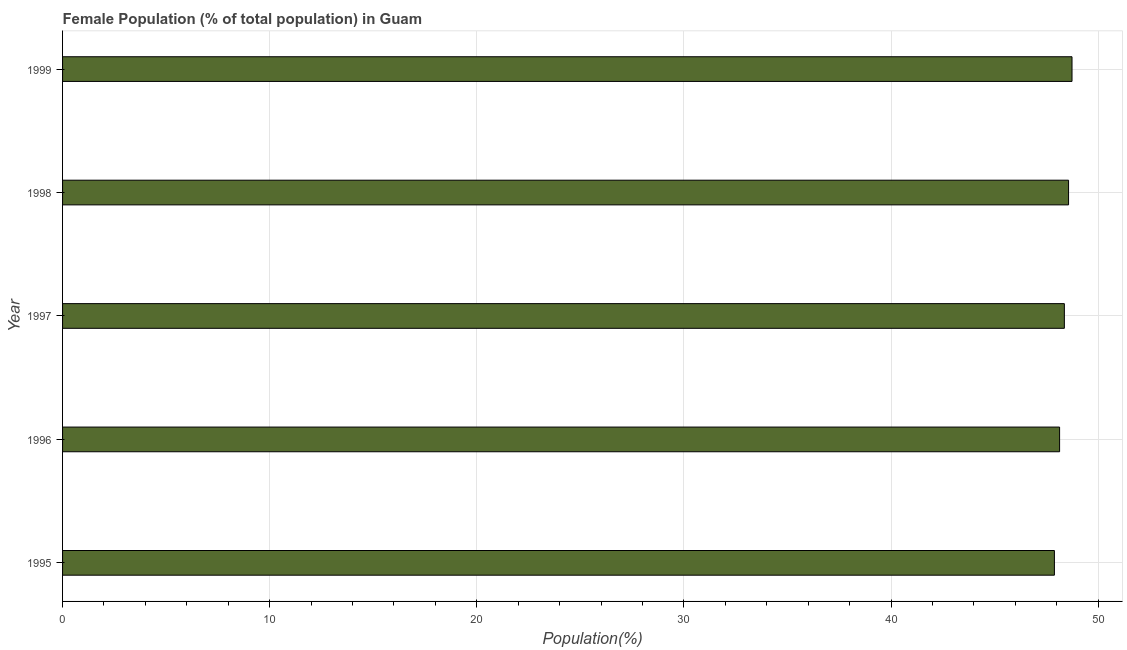What is the title of the graph?
Your answer should be compact. Female Population (% of total population) in Guam. What is the label or title of the X-axis?
Keep it short and to the point. Population(%). What is the female population in 1998?
Provide a succinct answer. 48.57. Across all years, what is the maximum female population?
Provide a succinct answer. 48.74. Across all years, what is the minimum female population?
Ensure brevity in your answer.  47.89. In which year was the female population minimum?
Make the answer very short. 1995. What is the sum of the female population?
Give a very brief answer. 241.7. What is the difference between the female population in 1995 and 1998?
Offer a terse response. -0.68. What is the average female population per year?
Make the answer very short. 48.34. What is the median female population?
Provide a succinct answer. 48.37. In how many years, is the female population greater than 22 %?
Provide a short and direct response. 5. Do a majority of the years between 1999 and 1996 (inclusive) have female population greater than 20 %?
Your response must be concise. Yes. What is the ratio of the female population in 1996 to that in 1998?
Your answer should be very brief. 0.99. Is the female population in 1997 less than that in 1999?
Your answer should be very brief. Yes. What is the difference between the highest and the second highest female population?
Make the answer very short. 0.17. What is the difference between the highest and the lowest female population?
Offer a terse response. 0.85. How many bars are there?
Offer a very short reply. 5. Are all the bars in the graph horizontal?
Your answer should be compact. Yes. How many years are there in the graph?
Your answer should be compact. 5. Are the values on the major ticks of X-axis written in scientific E-notation?
Your answer should be very brief. No. What is the Population(%) of 1995?
Ensure brevity in your answer.  47.89. What is the Population(%) of 1996?
Ensure brevity in your answer.  48.14. What is the Population(%) in 1997?
Keep it short and to the point. 48.37. What is the Population(%) in 1998?
Offer a terse response. 48.57. What is the Population(%) of 1999?
Give a very brief answer. 48.74. What is the difference between the Population(%) in 1995 and 1996?
Give a very brief answer. -0.25. What is the difference between the Population(%) in 1995 and 1997?
Your response must be concise. -0.48. What is the difference between the Population(%) in 1995 and 1998?
Provide a short and direct response. -0.68. What is the difference between the Population(%) in 1995 and 1999?
Make the answer very short. -0.85. What is the difference between the Population(%) in 1996 and 1997?
Provide a succinct answer. -0.23. What is the difference between the Population(%) in 1996 and 1998?
Offer a very short reply. -0.43. What is the difference between the Population(%) in 1996 and 1999?
Make the answer very short. -0.6. What is the difference between the Population(%) in 1997 and 1998?
Provide a succinct answer. -0.2. What is the difference between the Population(%) in 1997 and 1999?
Offer a terse response. -0.37. What is the difference between the Population(%) in 1998 and 1999?
Offer a very short reply. -0.17. What is the ratio of the Population(%) in 1995 to that in 1996?
Your response must be concise. 0.99. What is the ratio of the Population(%) in 1995 to that in 1997?
Keep it short and to the point. 0.99. What is the ratio of the Population(%) in 1995 to that in 1998?
Ensure brevity in your answer.  0.99. What is the ratio of the Population(%) in 1995 to that in 1999?
Provide a short and direct response. 0.98. What is the ratio of the Population(%) in 1997 to that in 1998?
Ensure brevity in your answer.  1. What is the ratio of the Population(%) in 1998 to that in 1999?
Make the answer very short. 1. 